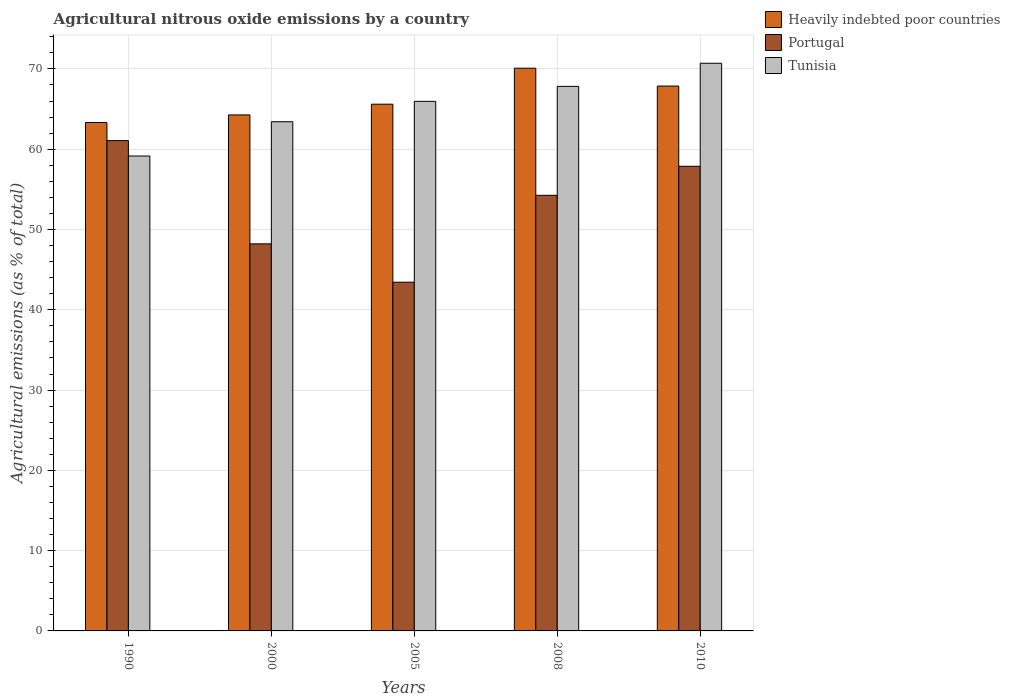How many different coloured bars are there?
Your response must be concise. 3. How many groups of bars are there?
Give a very brief answer. 5. Are the number of bars per tick equal to the number of legend labels?
Provide a short and direct response. Yes. How many bars are there on the 5th tick from the right?
Your answer should be compact. 3. In how many cases, is the number of bars for a given year not equal to the number of legend labels?
Your response must be concise. 0. What is the amount of agricultural nitrous oxide emitted in Heavily indebted poor countries in 2010?
Provide a short and direct response. 67.87. Across all years, what is the maximum amount of agricultural nitrous oxide emitted in Tunisia?
Your answer should be compact. 70.71. Across all years, what is the minimum amount of agricultural nitrous oxide emitted in Heavily indebted poor countries?
Make the answer very short. 63.33. In which year was the amount of agricultural nitrous oxide emitted in Tunisia minimum?
Your answer should be very brief. 1990. What is the total amount of agricultural nitrous oxide emitted in Tunisia in the graph?
Give a very brief answer. 327.08. What is the difference between the amount of agricultural nitrous oxide emitted in Tunisia in 1990 and that in 2000?
Ensure brevity in your answer.  -4.27. What is the difference between the amount of agricultural nitrous oxide emitted in Heavily indebted poor countries in 2000 and the amount of agricultural nitrous oxide emitted in Portugal in 2010?
Offer a very short reply. 6.4. What is the average amount of agricultural nitrous oxide emitted in Portugal per year?
Your answer should be very brief. 52.97. In the year 2005, what is the difference between the amount of agricultural nitrous oxide emitted in Heavily indebted poor countries and amount of agricultural nitrous oxide emitted in Portugal?
Make the answer very short. 22.17. In how many years, is the amount of agricultural nitrous oxide emitted in Tunisia greater than 32 %?
Give a very brief answer. 5. What is the ratio of the amount of agricultural nitrous oxide emitted in Tunisia in 2008 to that in 2010?
Keep it short and to the point. 0.96. Is the difference between the amount of agricultural nitrous oxide emitted in Heavily indebted poor countries in 1990 and 2008 greater than the difference between the amount of agricultural nitrous oxide emitted in Portugal in 1990 and 2008?
Keep it short and to the point. No. What is the difference between the highest and the second highest amount of agricultural nitrous oxide emitted in Tunisia?
Your response must be concise. 2.88. What is the difference between the highest and the lowest amount of agricultural nitrous oxide emitted in Heavily indebted poor countries?
Offer a terse response. 6.76. Is the sum of the amount of agricultural nitrous oxide emitted in Tunisia in 1990 and 2000 greater than the maximum amount of agricultural nitrous oxide emitted in Portugal across all years?
Keep it short and to the point. Yes. What does the 3rd bar from the left in 2010 represents?
Make the answer very short. Tunisia. What does the 3rd bar from the right in 2010 represents?
Give a very brief answer. Heavily indebted poor countries. What is the difference between two consecutive major ticks on the Y-axis?
Provide a short and direct response. 10. Are the values on the major ticks of Y-axis written in scientific E-notation?
Give a very brief answer. No. Where does the legend appear in the graph?
Offer a terse response. Top right. How many legend labels are there?
Make the answer very short. 3. How are the legend labels stacked?
Make the answer very short. Vertical. What is the title of the graph?
Your answer should be very brief. Agricultural nitrous oxide emissions by a country. What is the label or title of the X-axis?
Provide a short and direct response. Years. What is the label or title of the Y-axis?
Your answer should be very brief. Agricultural emissions (as % of total). What is the Agricultural emissions (as % of total) in Heavily indebted poor countries in 1990?
Offer a very short reply. 63.33. What is the Agricultural emissions (as % of total) of Portugal in 1990?
Make the answer very short. 61.07. What is the Agricultural emissions (as % of total) of Tunisia in 1990?
Your response must be concise. 59.15. What is the Agricultural emissions (as % of total) of Heavily indebted poor countries in 2000?
Give a very brief answer. 64.27. What is the Agricultural emissions (as % of total) in Portugal in 2000?
Make the answer very short. 48.21. What is the Agricultural emissions (as % of total) in Tunisia in 2000?
Provide a succinct answer. 63.42. What is the Agricultural emissions (as % of total) of Heavily indebted poor countries in 2005?
Your answer should be very brief. 65.61. What is the Agricultural emissions (as % of total) in Portugal in 2005?
Give a very brief answer. 43.44. What is the Agricultural emissions (as % of total) of Tunisia in 2005?
Offer a very short reply. 65.96. What is the Agricultural emissions (as % of total) in Heavily indebted poor countries in 2008?
Your answer should be compact. 70.09. What is the Agricultural emissions (as % of total) in Portugal in 2008?
Keep it short and to the point. 54.26. What is the Agricultural emissions (as % of total) in Tunisia in 2008?
Give a very brief answer. 67.83. What is the Agricultural emissions (as % of total) of Heavily indebted poor countries in 2010?
Provide a succinct answer. 67.87. What is the Agricultural emissions (as % of total) of Portugal in 2010?
Provide a short and direct response. 57.88. What is the Agricultural emissions (as % of total) in Tunisia in 2010?
Your response must be concise. 70.71. Across all years, what is the maximum Agricultural emissions (as % of total) of Heavily indebted poor countries?
Ensure brevity in your answer.  70.09. Across all years, what is the maximum Agricultural emissions (as % of total) of Portugal?
Your answer should be compact. 61.07. Across all years, what is the maximum Agricultural emissions (as % of total) of Tunisia?
Make the answer very short. 70.71. Across all years, what is the minimum Agricultural emissions (as % of total) in Heavily indebted poor countries?
Give a very brief answer. 63.33. Across all years, what is the minimum Agricultural emissions (as % of total) in Portugal?
Provide a succinct answer. 43.44. Across all years, what is the minimum Agricultural emissions (as % of total) of Tunisia?
Offer a terse response. 59.15. What is the total Agricultural emissions (as % of total) in Heavily indebted poor countries in the graph?
Provide a succinct answer. 331.17. What is the total Agricultural emissions (as % of total) in Portugal in the graph?
Provide a short and direct response. 264.86. What is the total Agricultural emissions (as % of total) of Tunisia in the graph?
Keep it short and to the point. 327.08. What is the difference between the Agricultural emissions (as % of total) in Heavily indebted poor countries in 1990 and that in 2000?
Provide a short and direct response. -0.94. What is the difference between the Agricultural emissions (as % of total) of Portugal in 1990 and that in 2000?
Make the answer very short. 12.86. What is the difference between the Agricultural emissions (as % of total) of Tunisia in 1990 and that in 2000?
Keep it short and to the point. -4.27. What is the difference between the Agricultural emissions (as % of total) in Heavily indebted poor countries in 1990 and that in 2005?
Your answer should be very brief. -2.28. What is the difference between the Agricultural emissions (as % of total) in Portugal in 1990 and that in 2005?
Provide a short and direct response. 17.63. What is the difference between the Agricultural emissions (as % of total) of Tunisia in 1990 and that in 2005?
Ensure brevity in your answer.  -6.81. What is the difference between the Agricultural emissions (as % of total) in Heavily indebted poor countries in 1990 and that in 2008?
Keep it short and to the point. -6.76. What is the difference between the Agricultural emissions (as % of total) of Portugal in 1990 and that in 2008?
Provide a succinct answer. 6.81. What is the difference between the Agricultural emissions (as % of total) in Tunisia in 1990 and that in 2008?
Ensure brevity in your answer.  -8.67. What is the difference between the Agricultural emissions (as % of total) in Heavily indebted poor countries in 1990 and that in 2010?
Provide a short and direct response. -4.54. What is the difference between the Agricultural emissions (as % of total) in Portugal in 1990 and that in 2010?
Keep it short and to the point. 3.2. What is the difference between the Agricultural emissions (as % of total) in Tunisia in 1990 and that in 2010?
Keep it short and to the point. -11.55. What is the difference between the Agricultural emissions (as % of total) of Heavily indebted poor countries in 2000 and that in 2005?
Give a very brief answer. -1.33. What is the difference between the Agricultural emissions (as % of total) in Portugal in 2000 and that in 2005?
Ensure brevity in your answer.  4.78. What is the difference between the Agricultural emissions (as % of total) of Tunisia in 2000 and that in 2005?
Provide a short and direct response. -2.54. What is the difference between the Agricultural emissions (as % of total) in Heavily indebted poor countries in 2000 and that in 2008?
Keep it short and to the point. -5.82. What is the difference between the Agricultural emissions (as % of total) of Portugal in 2000 and that in 2008?
Offer a very short reply. -6.05. What is the difference between the Agricultural emissions (as % of total) of Tunisia in 2000 and that in 2008?
Provide a short and direct response. -4.4. What is the difference between the Agricultural emissions (as % of total) of Heavily indebted poor countries in 2000 and that in 2010?
Give a very brief answer. -3.59. What is the difference between the Agricultural emissions (as % of total) in Portugal in 2000 and that in 2010?
Your answer should be compact. -9.66. What is the difference between the Agricultural emissions (as % of total) of Tunisia in 2000 and that in 2010?
Provide a short and direct response. -7.28. What is the difference between the Agricultural emissions (as % of total) of Heavily indebted poor countries in 2005 and that in 2008?
Offer a terse response. -4.49. What is the difference between the Agricultural emissions (as % of total) in Portugal in 2005 and that in 2008?
Ensure brevity in your answer.  -10.82. What is the difference between the Agricultural emissions (as % of total) of Tunisia in 2005 and that in 2008?
Keep it short and to the point. -1.86. What is the difference between the Agricultural emissions (as % of total) in Heavily indebted poor countries in 2005 and that in 2010?
Give a very brief answer. -2.26. What is the difference between the Agricultural emissions (as % of total) of Portugal in 2005 and that in 2010?
Provide a succinct answer. -14.44. What is the difference between the Agricultural emissions (as % of total) in Tunisia in 2005 and that in 2010?
Give a very brief answer. -4.75. What is the difference between the Agricultural emissions (as % of total) of Heavily indebted poor countries in 2008 and that in 2010?
Give a very brief answer. 2.23. What is the difference between the Agricultural emissions (as % of total) in Portugal in 2008 and that in 2010?
Keep it short and to the point. -3.62. What is the difference between the Agricultural emissions (as % of total) in Tunisia in 2008 and that in 2010?
Give a very brief answer. -2.88. What is the difference between the Agricultural emissions (as % of total) in Heavily indebted poor countries in 1990 and the Agricultural emissions (as % of total) in Portugal in 2000?
Provide a short and direct response. 15.12. What is the difference between the Agricultural emissions (as % of total) of Heavily indebted poor countries in 1990 and the Agricultural emissions (as % of total) of Tunisia in 2000?
Make the answer very short. -0.1. What is the difference between the Agricultural emissions (as % of total) in Portugal in 1990 and the Agricultural emissions (as % of total) in Tunisia in 2000?
Your answer should be very brief. -2.35. What is the difference between the Agricultural emissions (as % of total) in Heavily indebted poor countries in 1990 and the Agricultural emissions (as % of total) in Portugal in 2005?
Keep it short and to the point. 19.89. What is the difference between the Agricultural emissions (as % of total) of Heavily indebted poor countries in 1990 and the Agricultural emissions (as % of total) of Tunisia in 2005?
Offer a terse response. -2.63. What is the difference between the Agricultural emissions (as % of total) of Portugal in 1990 and the Agricultural emissions (as % of total) of Tunisia in 2005?
Your answer should be compact. -4.89. What is the difference between the Agricultural emissions (as % of total) of Heavily indebted poor countries in 1990 and the Agricultural emissions (as % of total) of Portugal in 2008?
Keep it short and to the point. 9.07. What is the difference between the Agricultural emissions (as % of total) of Heavily indebted poor countries in 1990 and the Agricultural emissions (as % of total) of Tunisia in 2008?
Offer a terse response. -4.5. What is the difference between the Agricultural emissions (as % of total) of Portugal in 1990 and the Agricultural emissions (as % of total) of Tunisia in 2008?
Your answer should be compact. -6.75. What is the difference between the Agricultural emissions (as % of total) in Heavily indebted poor countries in 1990 and the Agricultural emissions (as % of total) in Portugal in 2010?
Your answer should be compact. 5.45. What is the difference between the Agricultural emissions (as % of total) of Heavily indebted poor countries in 1990 and the Agricultural emissions (as % of total) of Tunisia in 2010?
Make the answer very short. -7.38. What is the difference between the Agricultural emissions (as % of total) in Portugal in 1990 and the Agricultural emissions (as % of total) in Tunisia in 2010?
Ensure brevity in your answer.  -9.64. What is the difference between the Agricultural emissions (as % of total) in Heavily indebted poor countries in 2000 and the Agricultural emissions (as % of total) in Portugal in 2005?
Your answer should be compact. 20.84. What is the difference between the Agricultural emissions (as % of total) of Heavily indebted poor countries in 2000 and the Agricultural emissions (as % of total) of Tunisia in 2005?
Your response must be concise. -1.69. What is the difference between the Agricultural emissions (as % of total) of Portugal in 2000 and the Agricultural emissions (as % of total) of Tunisia in 2005?
Your response must be concise. -17.75. What is the difference between the Agricultural emissions (as % of total) in Heavily indebted poor countries in 2000 and the Agricultural emissions (as % of total) in Portugal in 2008?
Your response must be concise. 10.01. What is the difference between the Agricultural emissions (as % of total) in Heavily indebted poor countries in 2000 and the Agricultural emissions (as % of total) in Tunisia in 2008?
Offer a very short reply. -3.55. What is the difference between the Agricultural emissions (as % of total) of Portugal in 2000 and the Agricultural emissions (as % of total) of Tunisia in 2008?
Offer a very short reply. -19.61. What is the difference between the Agricultural emissions (as % of total) in Heavily indebted poor countries in 2000 and the Agricultural emissions (as % of total) in Portugal in 2010?
Provide a short and direct response. 6.4. What is the difference between the Agricultural emissions (as % of total) in Heavily indebted poor countries in 2000 and the Agricultural emissions (as % of total) in Tunisia in 2010?
Keep it short and to the point. -6.43. What is the difference between the Agricultural emissions (as % of total) of Portugal in 2000 and the Agricultural emissions (as % of total) of Tunisia in 2010?
Offer a terse response. -22.5. What is the difference between the Agricultural emissions (as % of total) in Heavily indebted poor countries in 2005 and the Agricultural emissions (as % of total) in Portugal in 2008?
Your answer should be very brief. 11.35. What is the difference between the Agricultural emissions (as % of total) of Heavily indebted poor countries in 2005 and the Agricultural emissions (as % of total) of Tunisia in 2008?
Ensure brevity in your answer.  -2.22. What is the difference between the Agricultural emissions (as % of total) of Portugal in 2005 and the Agricultural emissions (as % of total) of Tunisia in 2008?
Make the answer very short. -24.39. What is the difference between the Agricultural emissions (as % of total) in Heavily indebted poor countries in 2005 and the Agricultural emissions (as % of total) in Portugal in 2010?
Your answer should be very brief. 7.73. What is the difference between the Agricultural emissions (as % of total) in Heavily indebted poor countries in 2005 and the Agricultural emissions (as % of total) in Tunisia in 2010?
Your answer should be compact. -5.1. What is the difference between the Agricultural emissions (as % of total) in Portugal in 2005 and the Agricultural emissions (as % of total) in Tunisia in 2010?
Ensure brevity in your answer.  -27.27. What is the difference between the Agricultural emissions (as % of total) of Heavily indebted poor countries in 2008 and the Agricultural emissions (as % of total) of Portugal in 2010?
Ensure brevity in your answer.  12.22. What is the difference between the Agricultural emissions (as % of total) of Heavily indebted poor countries in 2008 and the Agricultural emissions (as % of total) of Tunisia in 2010?
Give a very brief answer. -0.61. What is the difference between the Agricultural emissions (as % of total) of Portugal in 2008 and the Agricultural emissions (as % of total) of Tunisia in 2010?
Ensure brevity in your answer.  -16.45. What is the average Agricultural emissions (as % of total) of Heavily indebted poor countries per year?
Provide a succinct answer. 66.23. What is the average Agricultural emissions (as % of total) of Portugal per year?
Provide a succinct answer. 52.97. What is the average Agricultural emissions (as % of total) of Tunisia per year?
Give a very brief answer. 65.42. In the year 1990, what is the difference between the Agricultural emissions (as % of total) of Heavily indebted poor countries and Agricultural emissions (as % of total) of Portugal?
Offer a very short reply. 2.26. In the year 1990, what is the difference between the Agricultural emissions (as % of total) of Heavily indebted poor countries and Agricultural emissions (as % of total) of Tunisia?
Ensure brevity in your answer.  4.17. In the year 1990, what is the difference between the Agricultural emissions (as % of total) in Portugal and Agricultural emissions (as % of total) in Tunisia?
Provide a succinct answer. 1.92. In the year 2000, what is the difference between the Agricultural emissions (as % of total) of Heavily indebted poor countries and Agricultural emissions (as % of total) of Portugal?
Your response must be concise. 16.06. In the year 2000, what is the difference between the Agricultural emissions (as % of total) in Heavily indebted poor countries and Agricultural emissions (as % of total) in Tunisia?
Give a very brief answer. 0.85. In the year 2000, what is the difference between the Agricultural emissions (as % of total) in Portugal and Agricultural emissions (as % of total) in Tunisia?
Give a very brief answer. -15.21. In the year 2005, what is the difference between the Agricultural emissions (as % of total) of Heavily indebted poor countries and Agricultural emissions (as % of total) of Portugal?
Your answer should be compact. 22.17. In the year 2005, what is the difference between the Agricultural emissions (as % of total) of Heavily indebted poor countries and Agricultural emissions (as % of total) of Tunisia?
Provide a short and direct response. -0.35. In the year 2005, what is the difference between the Agricultural emissions (as % of total) in Portugal and Agricultural emissions (as % of total) in Tunisia?
Keep it short and to the point. -22.52. In the year 2008, what is the difference between the Agricultural emissions (as % of total) in Heavily indebted poor countries and Agricultural emissions (as % of total) in Portugal?
Offer a very short reply. 15.83. In the year 2008, what is the difference between the Agricultural emissions (as % of total) in Heavily indebted poor countries and Agricultural emissions (as % of total) in Tunisia?
Make the answer very short. 2.27. In the year 2008, what is the difference between the Agricultural emissions (as % of total) of Portugal and Agricultural emissions (as % of total) of Tunisia?
Ensure brevity in your answer.  -13.57. In the year 2010, what is the difference between the Agricultural emissions (as % of total) of Heavily indebted poor countries and Agricultural emissions (as % of total) of Portugal?
Provide a succinct answer. 9.99. In the year 2010, what is the difference between the Agricultural emissions (as % of total) in Heavily indebted poor countries and Agricultural emissions (as % of total) in Tunisia?
Ensure brevity in your answer.  -2.84. In the year 2010, what is the difference between the Agricultural emissions (as % of total) in Portugal and Agricultural emissions (as % of total) in Tunisia?
Provide a short and direct response. -12.83. What is the ratio of the Agricultural emissions (as % of total) of Heavily indebted poor countries in 1990 to that in 2000?
Make the answer very short. 0.99. What is the ratio of the Agricultural emissions (as % of total) of Portugal in 1990 to that in 2000?
Your answer should be very brief. 1.27. What is the ratio of the Agricultural emissions (as % of total) in Tunisia in 1990 to that in 2000?
Your answer should be compact. 0.93. What is the ratio of the Agricultural emissions (as % of total) of Heavily indebted poor countries in 1990 to that in 2005?
Ensure brevity in your answer.  0.97. What is the ratio of the Agricultural emissions (as % of total) in Portugal in 1990 to that in 2005?
Offer a very short reply. 1.41. What is the ratio of the Agricultural emissions (as % of total) in Tunisia in 1990 to that in 2005?
Your answer should be compact. 0.9. What is the ratio of the Agricultural emissions (as % of total) of Heavily indebted poor countries in 1990 to that in 2008?
Your response must be concise. 0.9. What is the ratio of the Agricultural emissions (as % of total) in Portugal in 1990 to that in 2008?
Offer a very short reply. 1.13. What is the ratio of the Agricultural emissions (as % of total) of Tunisia in 1990 to that in 2008?
Your response must be concise. 0.87. What is the ratio of the Agricultural emissions (as % of total) of Heavily indebted poor countries in 1990 to that in 2010?
Ensure brevity in your answer.  0.93. What is the ratio of the Agricultural emissions (as % of total) of Portugal in 1990 to that in 2010?
Your answer should be very brief. 1.06. What is the ratio of the Agricultural emissions (as % of total) of Tunisia in 1990 to that in 2010?
Your response must be concise. 0.84. What is the ratio of the Agricultural emissions (as % of total) in Heavily indebted poor countries in 2000 to that in 2005?
Offer a very short reply. 0.98. What is the ratio of the Agricultural emissions (as % of total) of Portugal in 2000 to that in 2005?
Your answer should be compact. 1.11. What is the ratio of the Agricultural emissions (as % of total) of Tunisia in 2000 to that in 2005?
Your response must be concise. 0.96. What is the ratio of the Agricultural emissions (as % of total) of Heavily indebted poor countries in 2000 to that in 2008?
Keep it short and to the point. 0.92. What is the ratio of the Agricultural emissions (as % of total) of Portugal in 2000 to that in 2008?
Make the answer very short. 0.89. What is the ratio of the Agricultural emissions (as % of total) in Tunisia in 2000 to that in 2008?
Your answer should be very brief. 0.94. What is the ratio of the Agricultural emissions (as % of total) in Heavily indebted poor countries in 2000 to that in 2010?
Offer a very short reply. 0.95. What is the ratio of the Agricultural emissions (as % of total) of Portugal in 2000 to that in 2010?
Offer a terse response. 0.83. What is the ratio of the Agricultural emissions (as % of total) of Tunisia in 2000 to that in 2010?
Ensure brevity in your answer.  0.9. What is the ratio of the Agricultural emissions (as % of total) of Heavily indebted poor countries in 2005 to that in 2008?
Offer a terse response. 0.94. What is the ratio of the Agricultural emissions (as % of total) in Portugal in 2005 to that in 2008?
Your answer should be compact. 0.8. What is the ratio of the Agricultural emissions (as % of total) of Tunisia in 2005 to that in 2008?
Offer a very short reply. 0.97. What is the ratio of the Agricultural emissions (as % of total) in Heavily indebted poor countries in 2005 to that in 2010?
Your answer should be compact. 0.97. What is the ratio of the Agricultural emissions (as % of total) of Portugal in 2005 to that in 2010?
Your answer should be compact. 0.75. What is the ratio of the Agricultural emissions (as % of total) of Tunisia in 2005 to that in 2010?
Your response must be concise. 0.93. What is the ratio of the Agricultural emissions (as % of total) in Heavily indebted poor countries in 2008 to that in 2010?
Offer a very short reply. 1.03. What is the ratio of the Agricultural emissions (as % of total) in Tunisia in 2008 to that in 2010?
Give a very brief answer. 0.96. What is the difference between the highest and the second highest Agricultural emissions (as % of total) in Heavily indebted poor countries?
Your answer should be very brief. 2.23. What is the difference between the highest and the second highest Agricultural emissions (as % of total) of Portugal?
Provide a short and direct response. 3.2. What is the difference between the highest and the second highest Agricultural emissions (as % of total) in Tunisia?
Offer a very short reply. 2.88. What is the difference between the highest and the lowest Agricultural emissions (as % of total) in Heavily indebted poor countries?
Ensure brevity in your answer.  6.76. What is the difference between the highest and the lowest Agricultural emissions (as % of total) of Portugal?
Your answer should be very brief. 17.63. What is the difference between the highest and the lowest Agricultural emissions (as % of total) in Tunisia?
Offer a terse response. 11.55. 